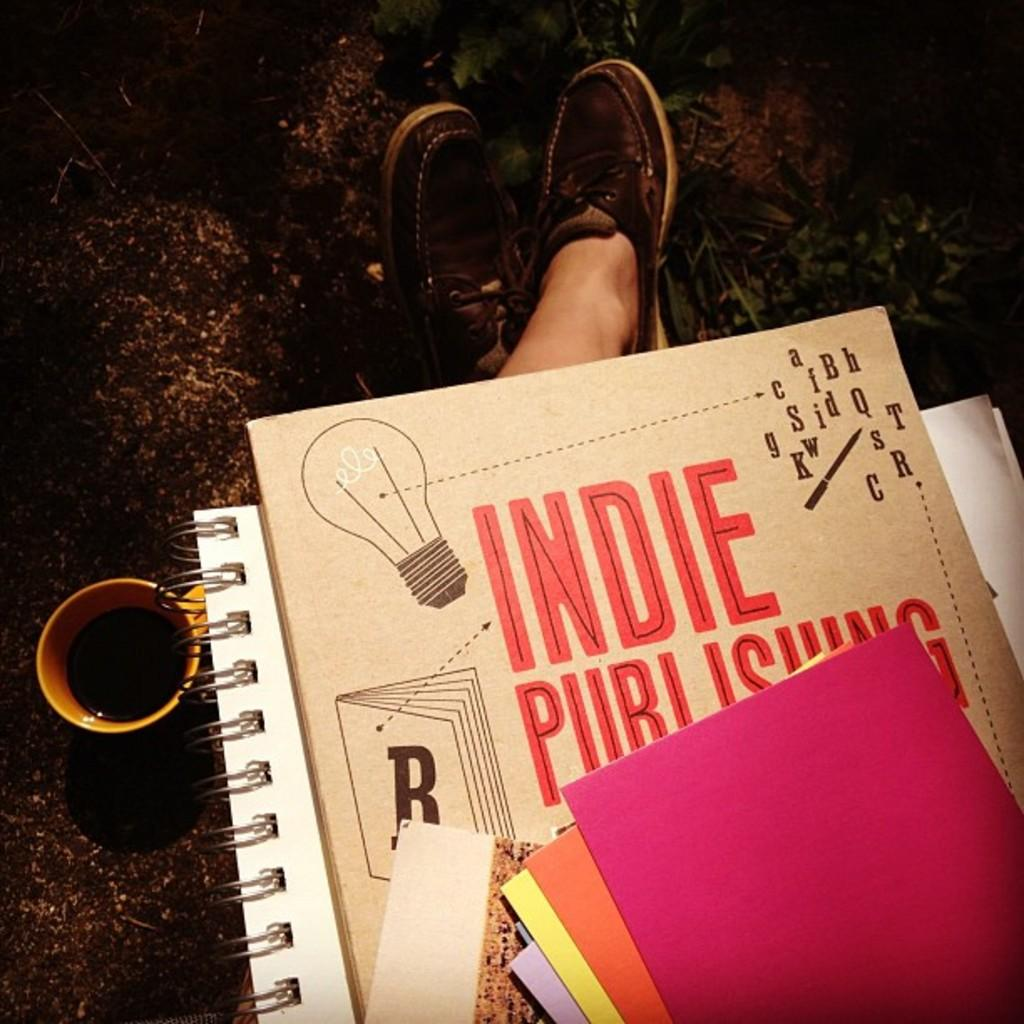<image>
Create a compact narrative representing the image presented. a card and notebook, the card reading Indie Publishing. 